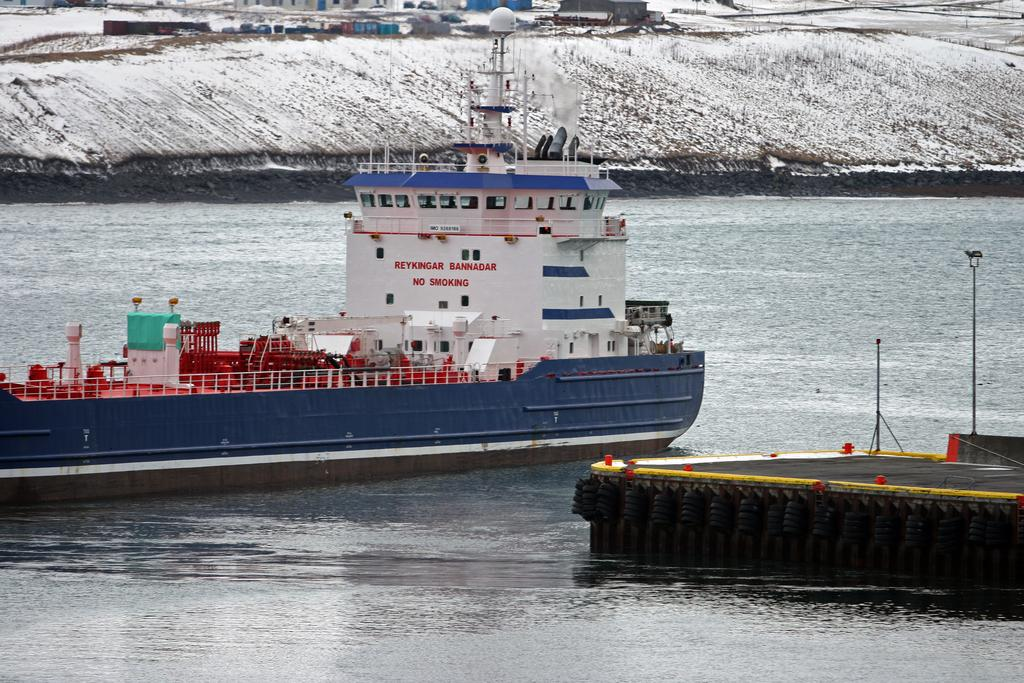What is at the bottom of the image? There is water at the bottom of the image. What is in the water? There is a ship in the water. What can be seen in the background? There is snow visible in the background of the image. What type of holiday is being celebrated on the ship in the image? There is no indication of a holiday being celebrated on the ship in the image. What design elements can be seen on the ship's hull? The image does not provide enough detail to identify any specific design elements on the ship's hull. 